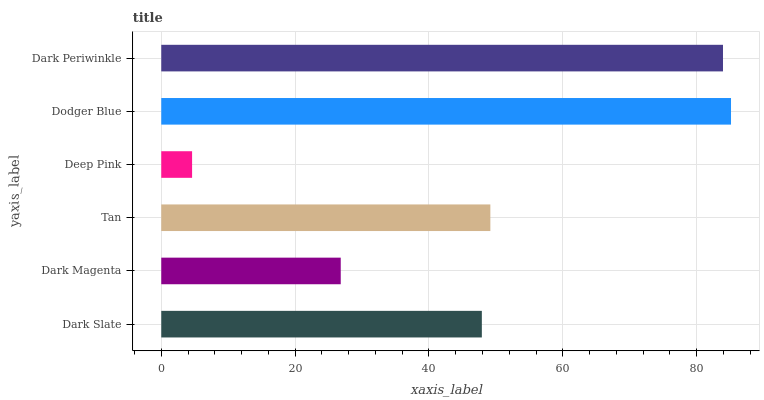Is Deep Pink the minimum?
Answer yes or no. Yes. Is Dodger Blue the maximum?
Answer yes or no. Yes. Is Dark Magenta the minimum?
Answer yes or no. No. Is Dark Magenta the maximum?
Answer yes or no. No. Is Dark Slate greater than Dark Magenta?
Answer yes or no. Yes. Is Dark Magenta less than Dark Slate?
Answer yes or no. Yes. Is Dark Magenta greater than Dark Slate?
Answer yes or no. No. Is Dark Slate less than Dark Magenta?
Answer yes or no. No. Is Tan the high median?
Answer yes or no. Yes. Is Dark Slate the low median?
Answer yes or no. Yes. Is Deep Pink the high median?
Answer yes or no. No. Is Dark Magenta the low median?
Answer yes or no. No. 